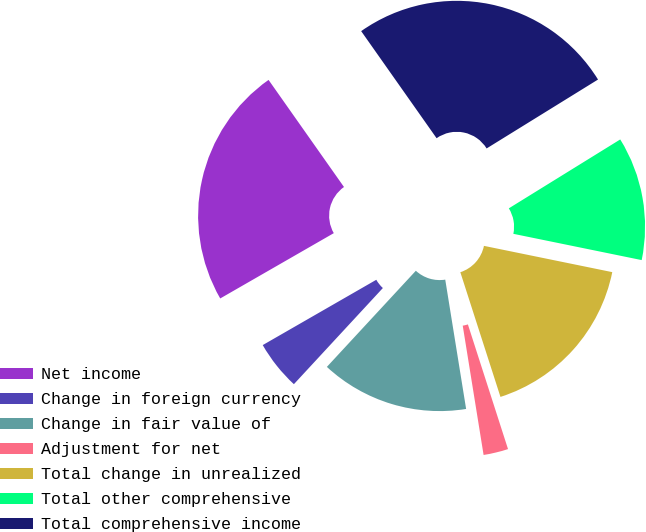<chart> <loc_0><loc_0><loc_500><loc_500><pie_chart><fcel>Net income<fcel>Change in foreign currency<fcel>Change in fair value of<fcel>Adjustment for net<fcel>Total change in unrealized<fcel>Total other comprehensive<fcel>Total comprehensive income<nl><fcel>23.54%<fcel>4.81%<fcel>14.43%<fcel>2.41%<fcel>16.83%<fcel>12.03%<fcel>25.95%<nl></chart> 